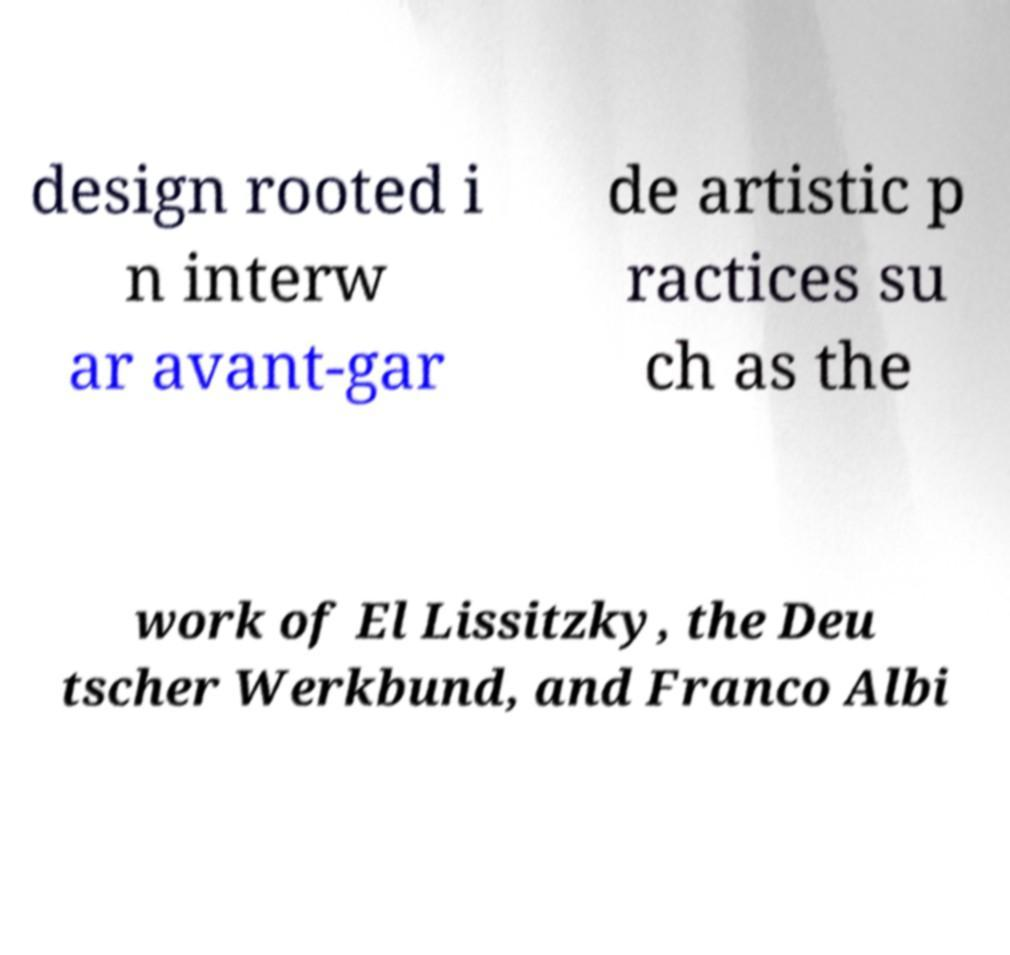What messages or text are displayed in this image? I need them in a readable, typed format. design rooted i n interw ar avant-gar de artistic p ractices su ch as the work of El Lissitzky, the Deu tscher Werkbund, and Franco Albi 